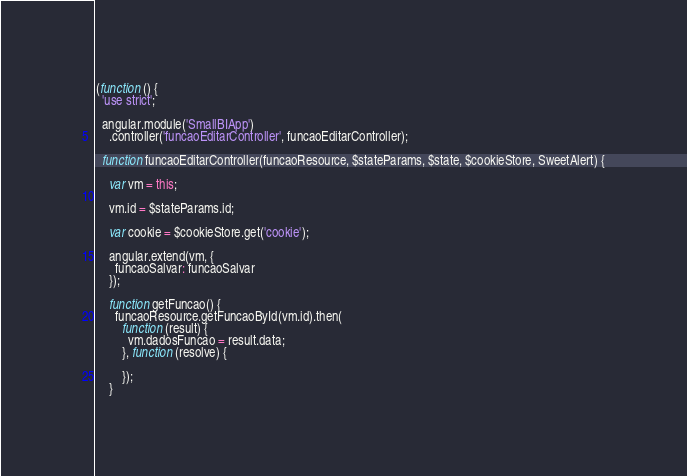<code> <loc_0><loc_0><loc_500><loc_500><_JavaScript_>(function () {
  'use strict';

  angular.module('SmallBIApp')
    .controller('funcaoEditarController', funcaoEditarController);

  function funcaoEditarController(funcaoResource, $stateParams, $state, $cookieStore, SweetAlert) {

    var vm = this;

    vm.id = $stateParams.id;

    var cookie = $cookieStore.get('cookie');

    angular.extend(vm, {
      funcaoSalvar: funcaoSalvar
    });

    function getFuncao() {
      funcaoResource.getFuncaoById(vm.id).then(
        function (result) {
          vm.dadosFuncao = result.data;
        }, function (resolve) {

        });
    }
</code> 